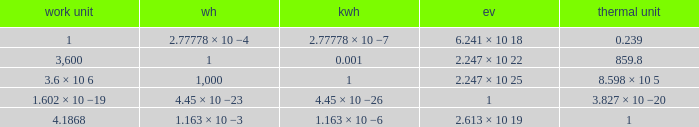How many calories is 1 watt hour? 859.8. 